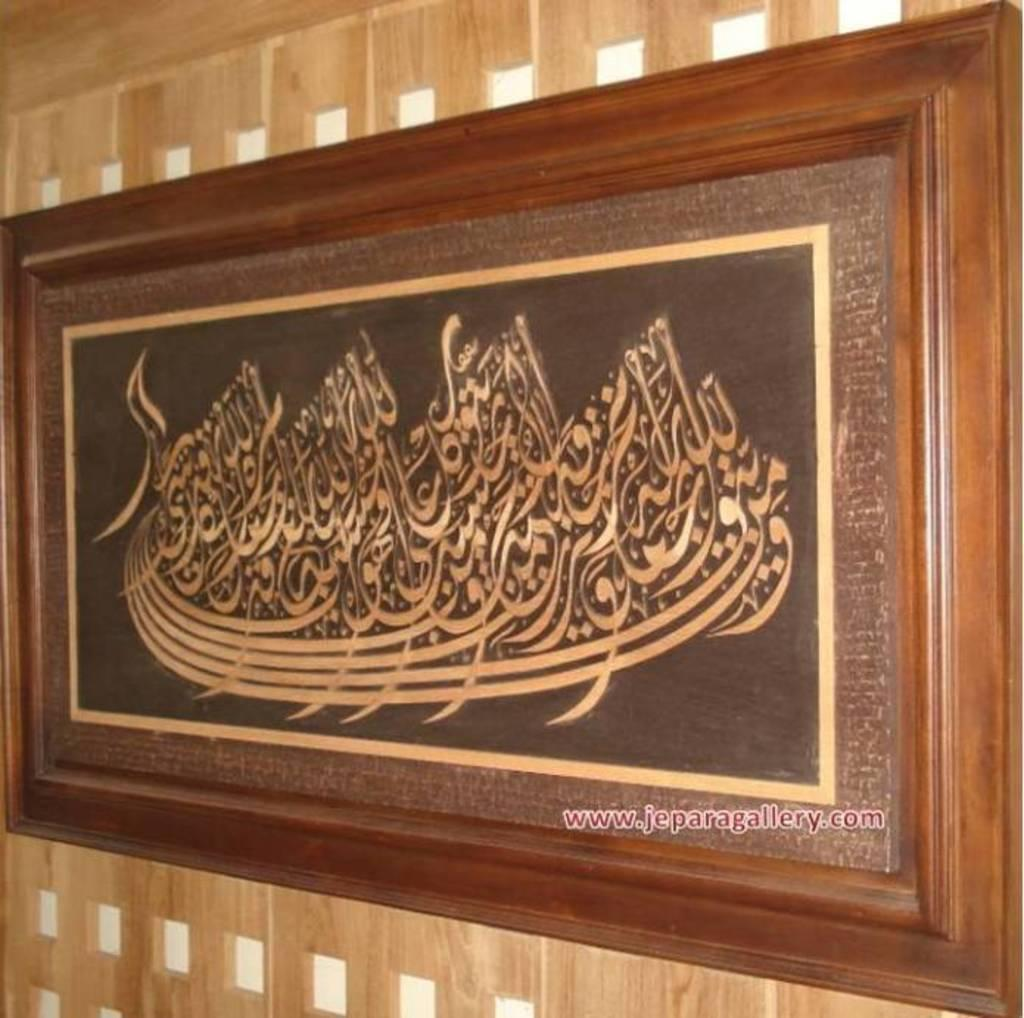What is hanging on the wall in the image? There is a frame on the wall in the image. Where can text be found in the image? Text can be found at the bottom right corner of the image. What type of throat-soothing remedy is present in the image? There is no throat-soothing remedy present in the image. What type of expansion can be seen in the image? There is no expansion visible in the image. 